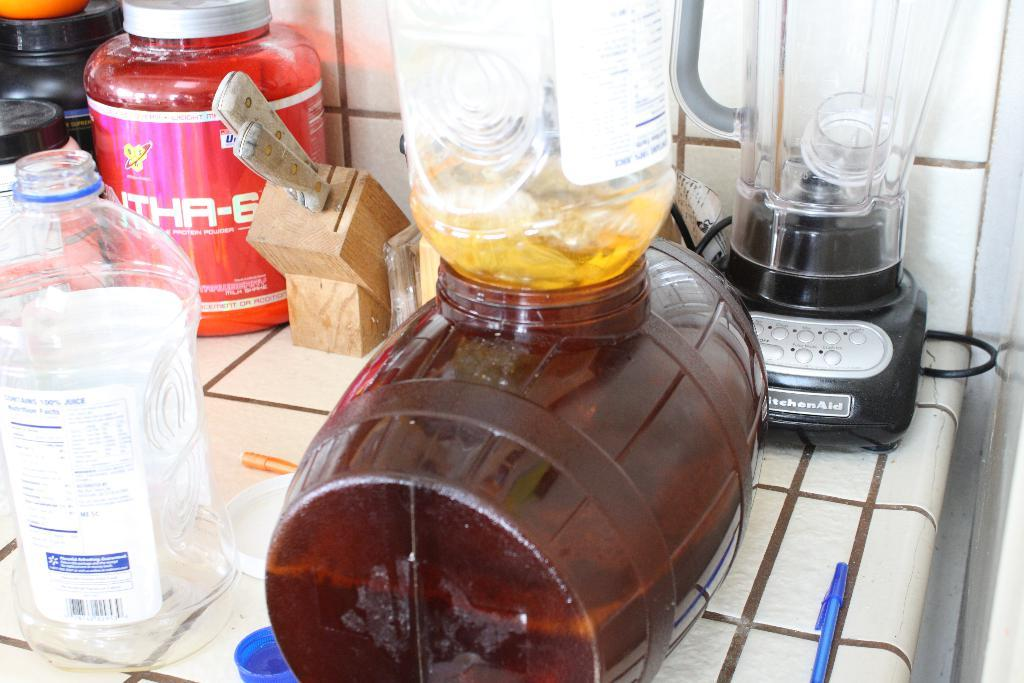<image>
Give a short and clear explanation of the subsequent image. A number of appliances on a kitchen counter in front of a Kitchenaid blender. 